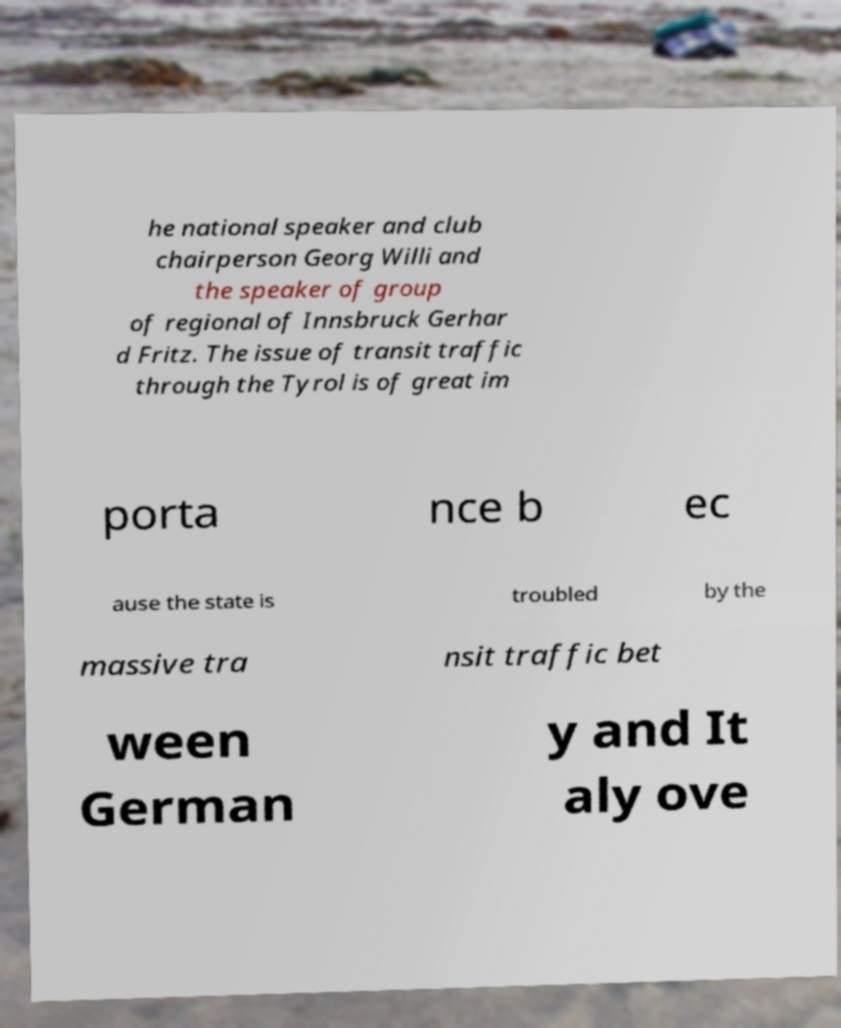Can you accurately transcribe the text from the provided image for me? he national speaker and club chairperson Georg Willi and the speaker of group of regional of Innsbruck Gerhar d Fritz. The issue of transit traffic through the Tyrol is of great im porta nce b ec ause the state is troubled by the massive tra nsit traffic bet ween German y and It aly ove 